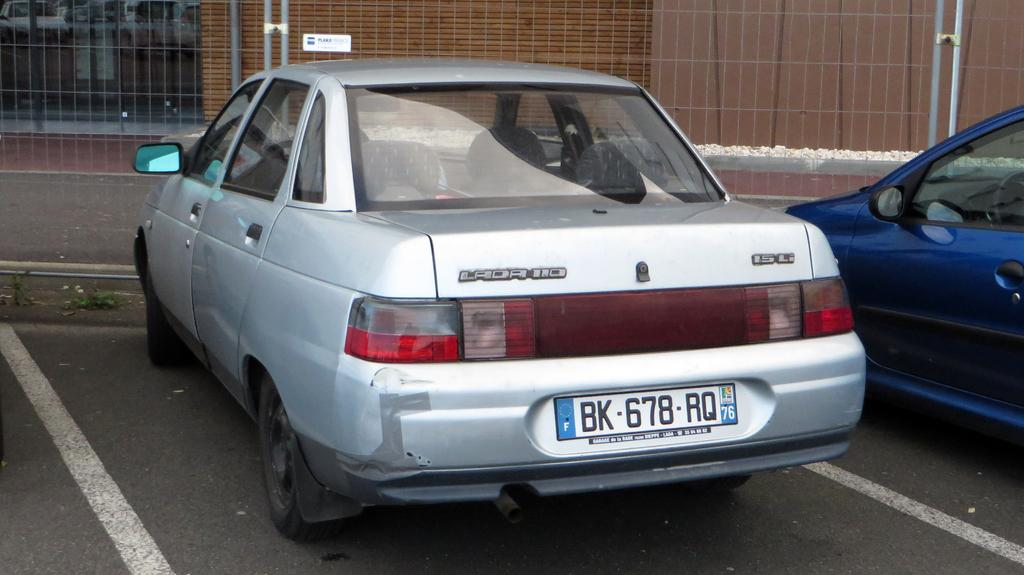How many cars can be seen on the road in the image? There are two cars on the road in the image. What can be observed on the cars in the image? The cars have number plates. What is located at the top of the image? There is a fence at the top of the image. What is behind the fence in the image? There is a wall with a window behind the fence. What type of dinner is the farmer preparing in the image? There is no farmer or dinner present in the image; it features two cars on the road and a fence with a wall and window behind it. 